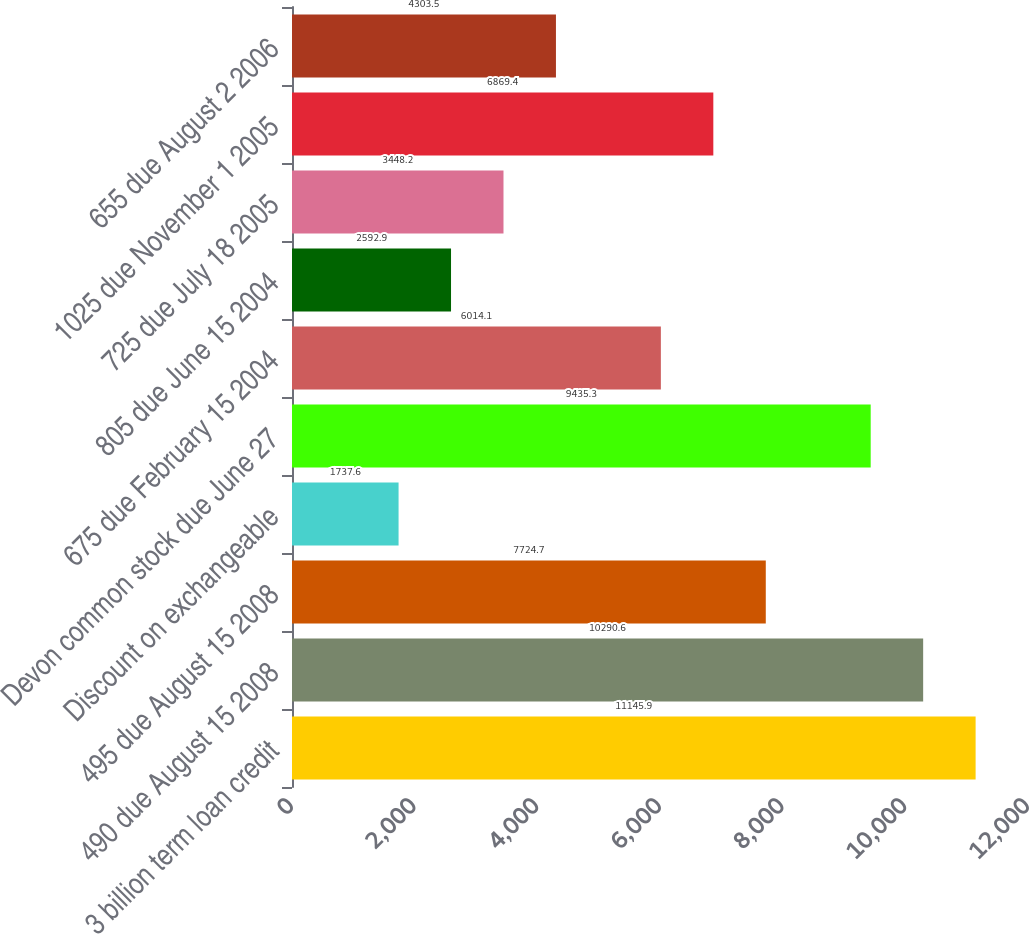Convert chart to OTSL. <chart><loc_0><loc_0><loc_500><loc_500><bar_chart><fcel>3 billion term loan credit<fcel>490 due August 15 2008<fcel>495 due August 15 2008<fcel>Discount on exchangeable<fcel>Devon common stock due June 27<fcel>675 due February 15 2004<fcel>805 due June 15 2004<fcel>725 due July 18 2005<fcel>1025 due November 1 2005<fcel>655 due August 2 2006<nl><fcel>11145.9<fcel>10290.6<fcel>7724.7<fcel>1737.6<fcel>9435.3<fcel>6014.1<fcel>2592.9<fcel>3448.2<fcel>6869.4<fcel>4303.5<nl></chart> 